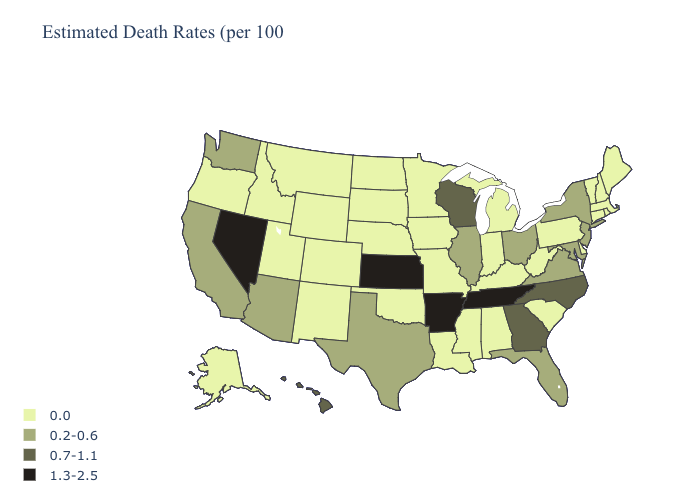Name the states that have a value in the range 1.3-2.5?
Short answer required. Arkansas, Kansas, Nevada, Tennessee. What is the highest value in the Northeast ?
Answer briefly. 0.2-0.6. How many symbols are there in the legend?
Quick response, please. 4. Does the map have missing data?
Be succinct. No. Does Maryland have a lower value than Hawaii?
Give a very brief answer. Yes. Does the first symbol in the legend represent the smallest category?
Quick response, please. Yes. Does New York have the lowest value in the USA?
Concise answer only. No. What is the value of Kansas?
Be succinct. 1.3-2.5. What is the highest value in states that border Wisconsin?
Answer briefly. 0.2-0.6. Which states have the lowest value in the USA?
Write a very short answer. Alabama, Alaska, Colorado, Connecticut, Delaware, Idaho, Indiana, Iowa, Kentucky, Louisiana, Maine, Massachusetts, Michigan, Minnesota, Mississippi, Missouri, Montana, Nebraska, New Hampshire, New Mexico, North Dakota, Oklahoma, Oregon, Pennsylvania, Rhode Island, South Carolina, South Dakota, Utah, Vermont, West Virginia, Wyoming. Is the legend a continuous bar?
Be succinct. No. Name the states that have a value in the range 1.3-2.5?
Answer briefly. Arkansas, Kansas, Nevada, Tennessee. Is the legend a continuous bar?
Give a very brief answer. No. Does the first symbol in the legend represent the smallest category?
Answer briefly. Yes. 